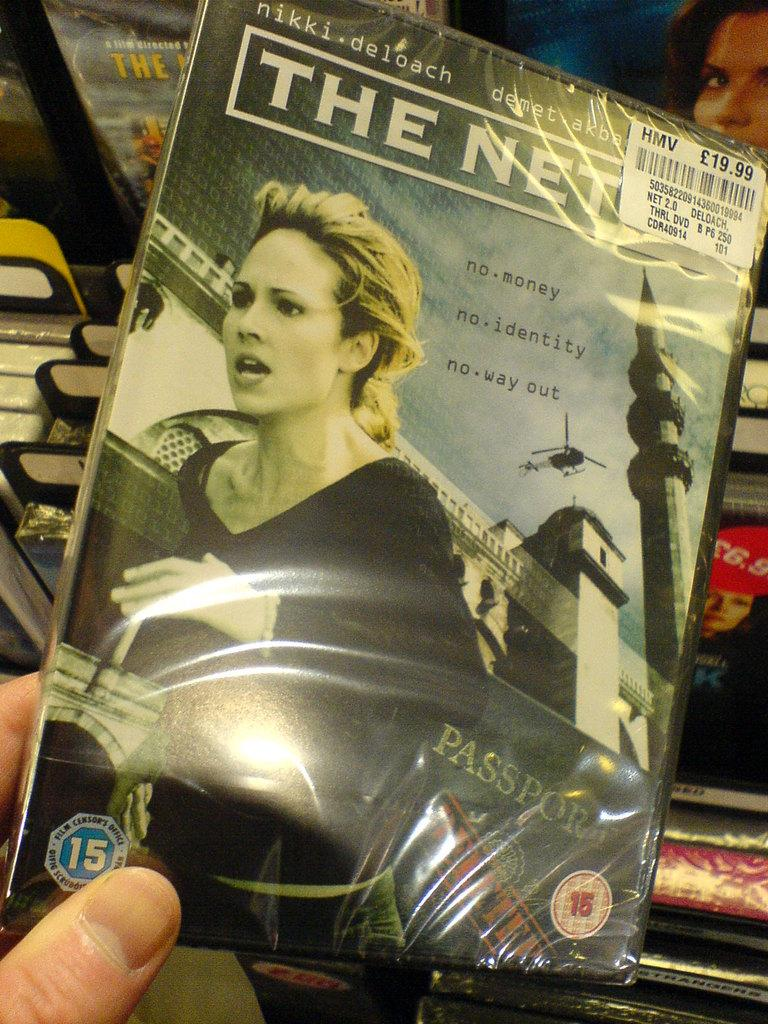<image>
Present a compact description of the photo's key features. A brand new, sealed DVD of a film called The Net 